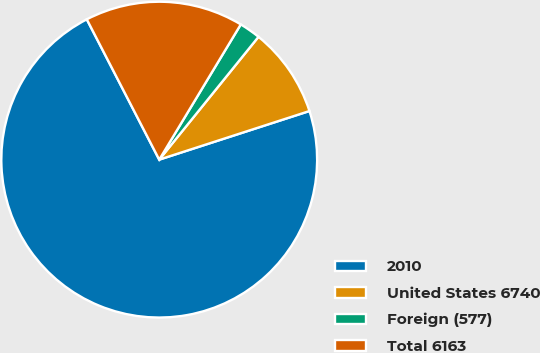Convert chart to OTSL. <chart><loc_0><loc_0><loc_500><loc_500><pie_chart><fcel>2010<fcel>United States 6740<fcel>Foreign (577)<fcel>Total 6163<nl><fcel>72.39%<fcel>9.2%<fcel>2.18%<fcel>16.22%<nl></chart> 